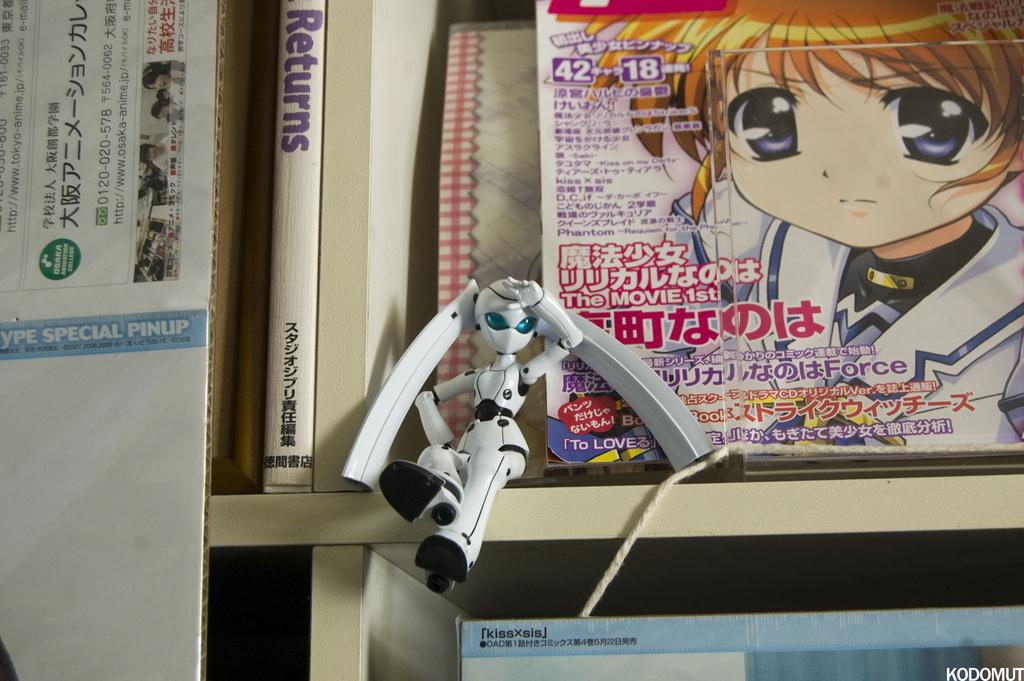<image>
Present a compact description of the photo's key features. An anime magazine sits next to a book titled Returns. 